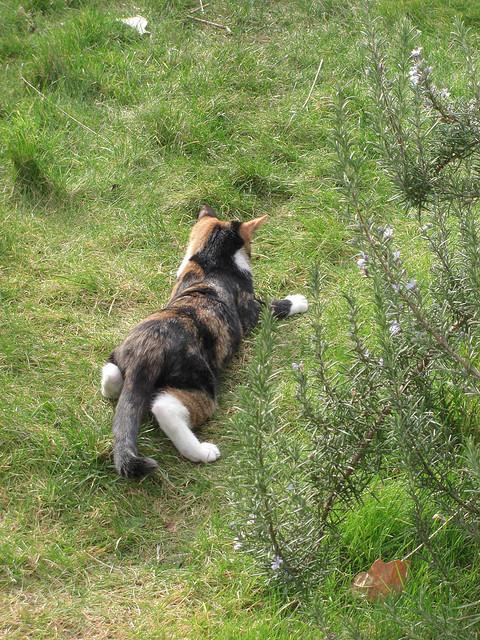What kind of animal is this?
Write a very short answer. Cat. Was this taken during the winter?
Keep it brief. No. Can you see its face?
Quick response, please. No. What is the pattern of the cat's fur?
Concise answer only. Calico. 